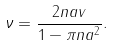Convert formula to latex. <formula><loc_0><loc_0><loc_500><loc_500>\nu = \frac { 2 n a v } { 1 - \pi n a ^ { 2 } } .</formula> 